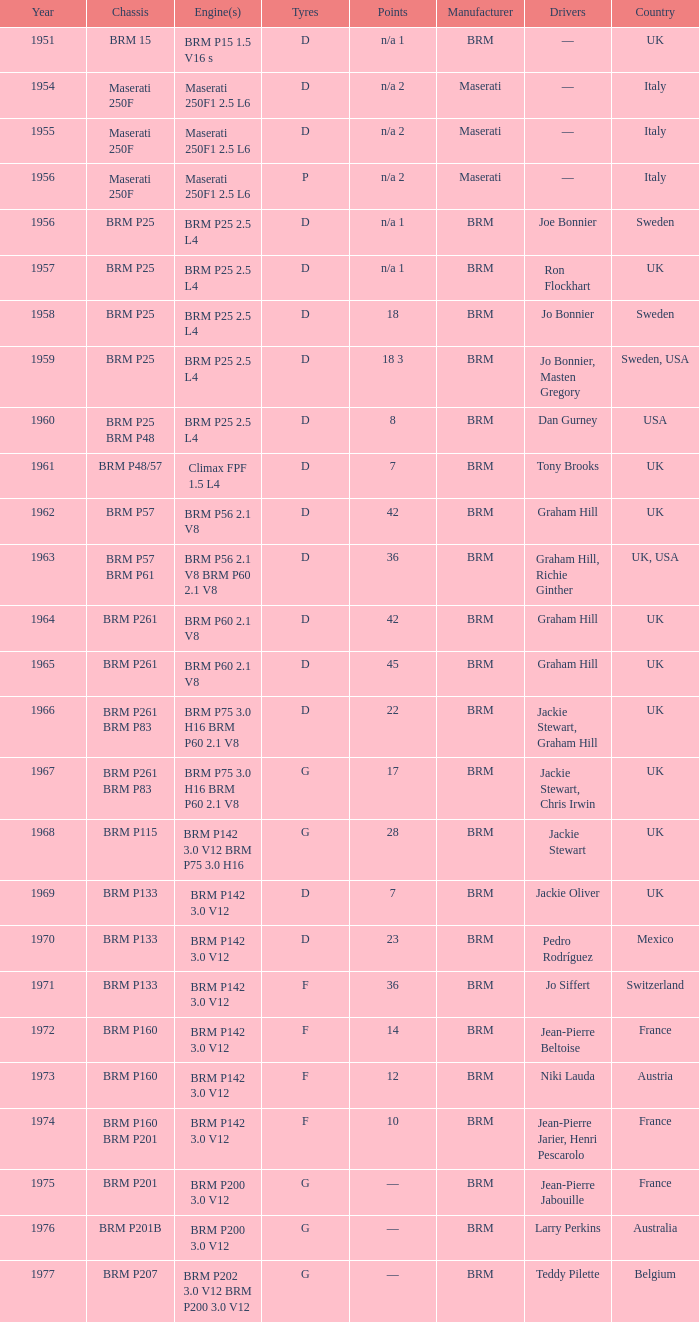What is the chassis model for 1961? BRM P48/57. 